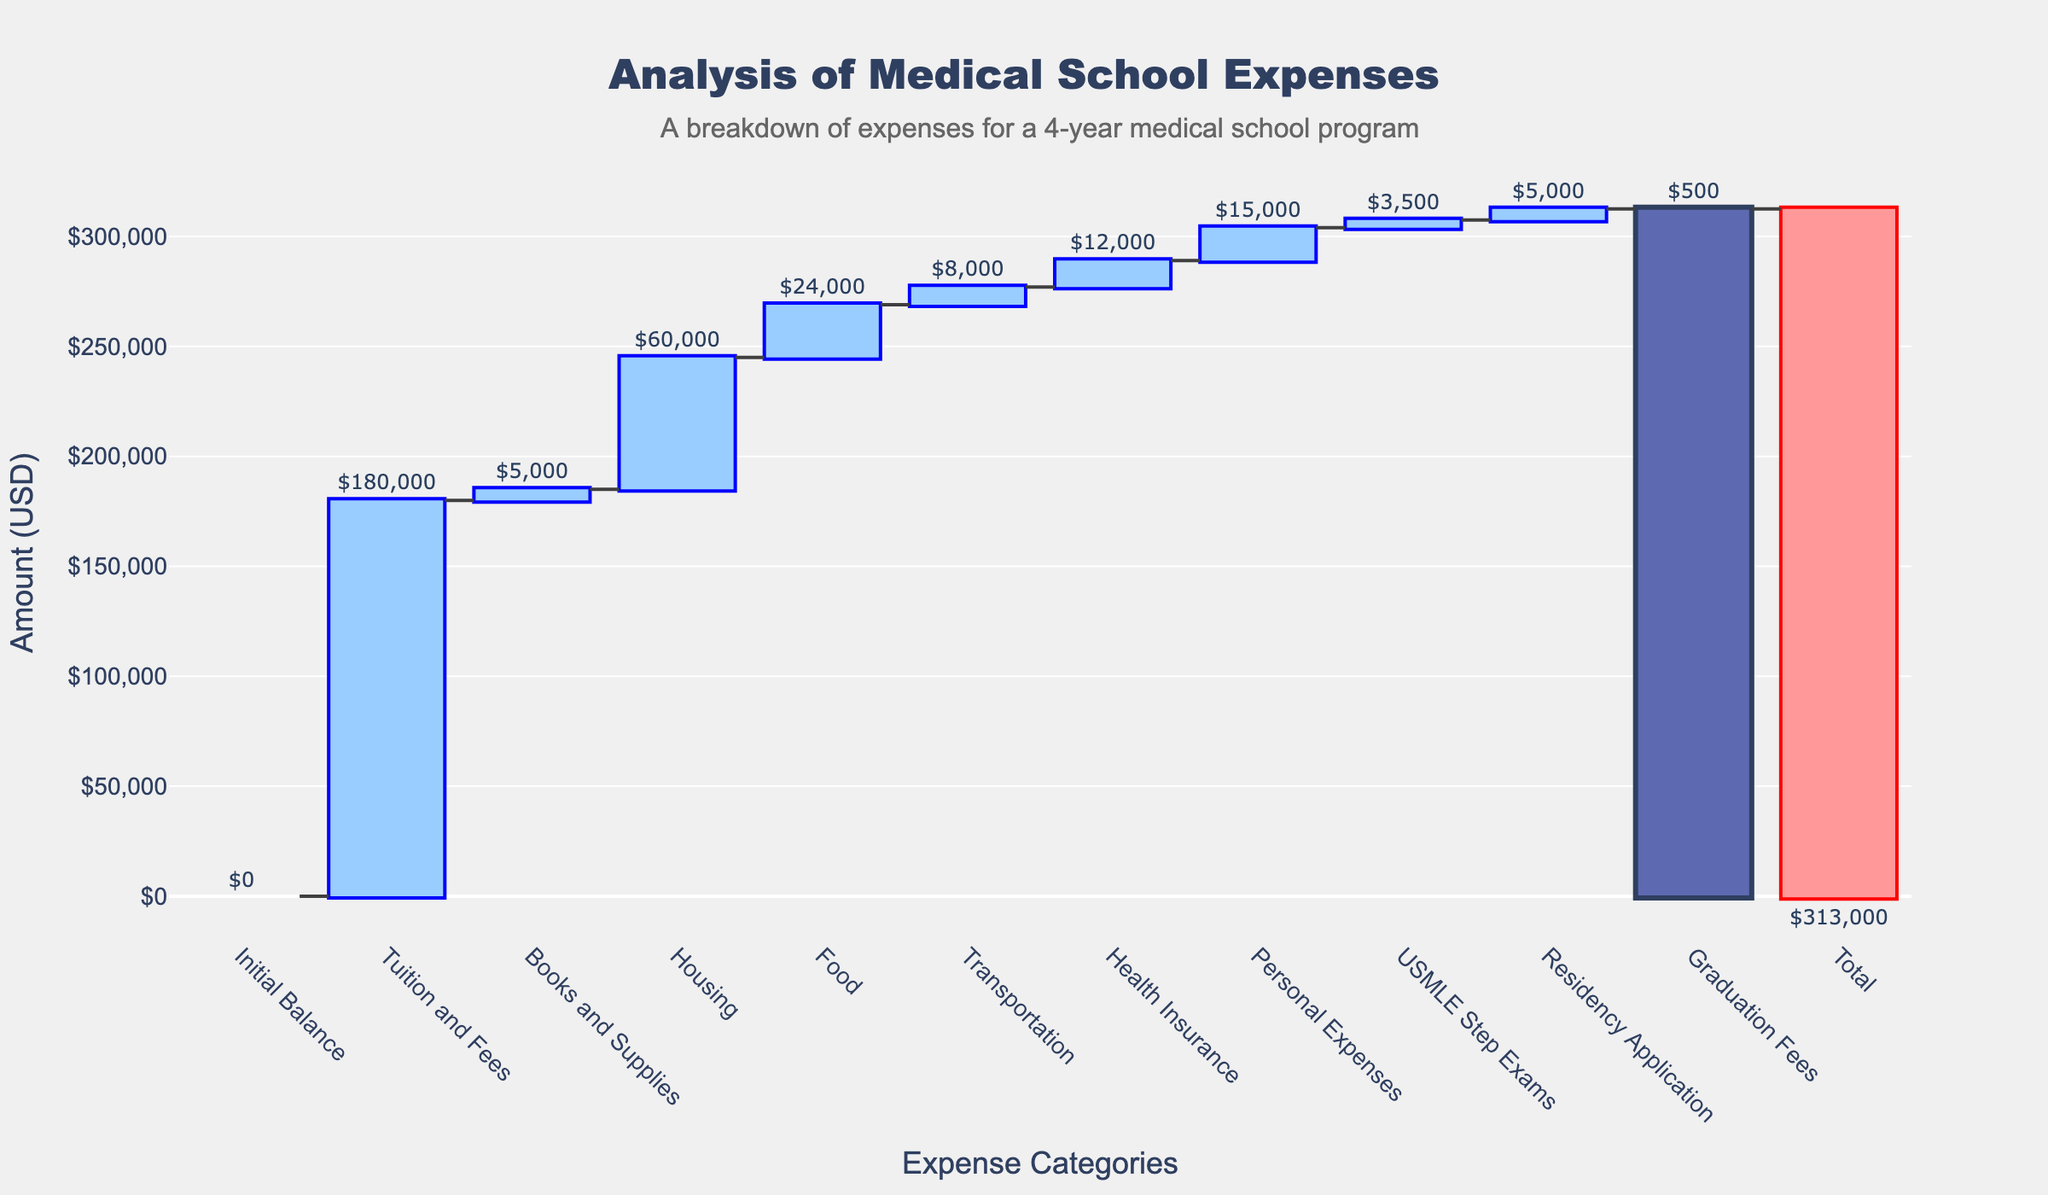What is the title of the chart? The title of the chart is displayed at the top of the figure. It summarizes the data being visualized in the chart.
Answer: Analysis of Medical School Expenses What category contributes the most to the total expenses? To find the category that contributes the most to the expenses, look for the bar that extends the highest upwards. This category has the largest amount.
Answer: Tuition and Fees How much is the total cost of medical school expenses according to the chart? The total cost is indicated by the very last bar, which represents the total sum of all expenses.
Answer: $313,000 Which category has the smallest amount in the expenses? Look for the bar that is the shortest among all categories. This bar represents the category with the smallest expenditure.
Answer: Graduation Fees What is the sum of expenses for Housing and Food? Identify the values for Housing and Food, then add them together. Housing is $60,000, and Food is $24,000.
Answer: $84,000 Compare the amount spent on Transportation and Personal Expenses. Which one is higher and by how much? Find the values for both categories and subtract the smaller amount from the larger one. Transportation is $8,000, and Personal Expenses is $15,000.
Answer: Personal Expenses is higher by $7,000 What is the difference in expenses between Health Insurance and Books and Supplies? Subtract the amount for Books and Supplies from the amount for Health Insurance. Health Insurance is $12,000, and Books and Supplies is $5,000.
Answer: $7,000 If you combine the costs of USMLE Step Exams and Residency Application, what is the total? Sum the amounts for USMLE Step Exams and Residency Application. USMLE Step Exams are $3,500, and Residency Application is $5,000.
Answer: $8,500 What percentage of the total expenses is spent on Housing? Divide the Housing expenses by the total expenses and multiply by 100 to get the percentage. Housing is $60,000, and the total is $313,000. Calculation: (60,000 / 313,000) * 100.
Answer: Approximately 19.17% In terms of expenses, which category is the second highest after Tuition and Fees? Identify and compare the amounts of each category, finding the second largest after Tuition and Fees ($180,000).
Answer: Housing 